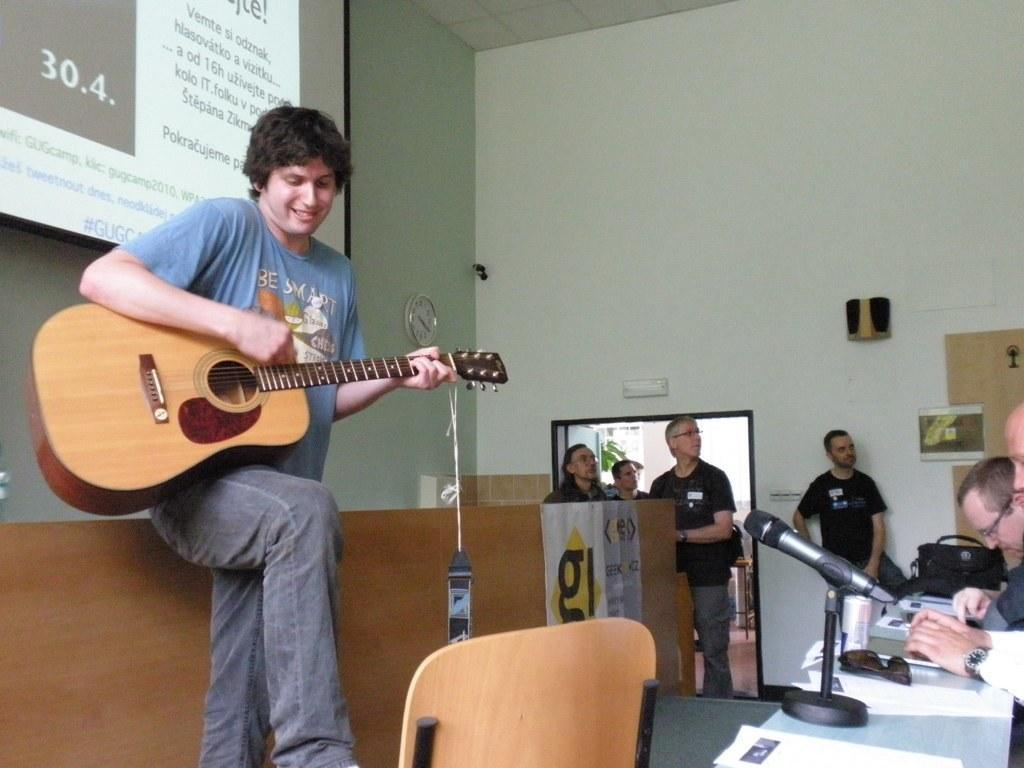Could you give a brief overview of what you see in this image? As we can see in he image there is a white color wall, screen, a man holding guitar in his hand, tables, chairs and on table there is a mike and papers. 